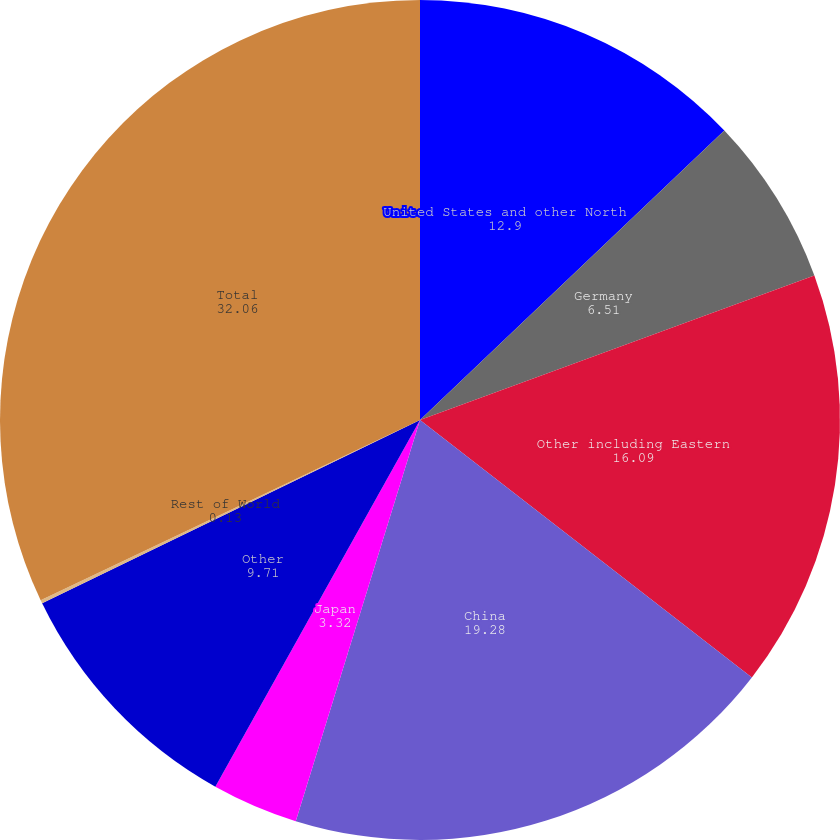Convert chart. <chart><loc_0><loc_0><loc_500><loc_500><pie_chart><fcel>United States and other North<fcel>Germany<fcel>Other including Eastern<fcel>China<fcel>Japan<fcel>Other<fcel>Rest of World<fcel>Total<nl><fcel>12.9%<fcel>6.51%<fcel>16.09%<fcel>19.28%<fcel>3.32%<fcel>9.71%<fcel>0.13%<fcel>32.06%<nl></chart> 